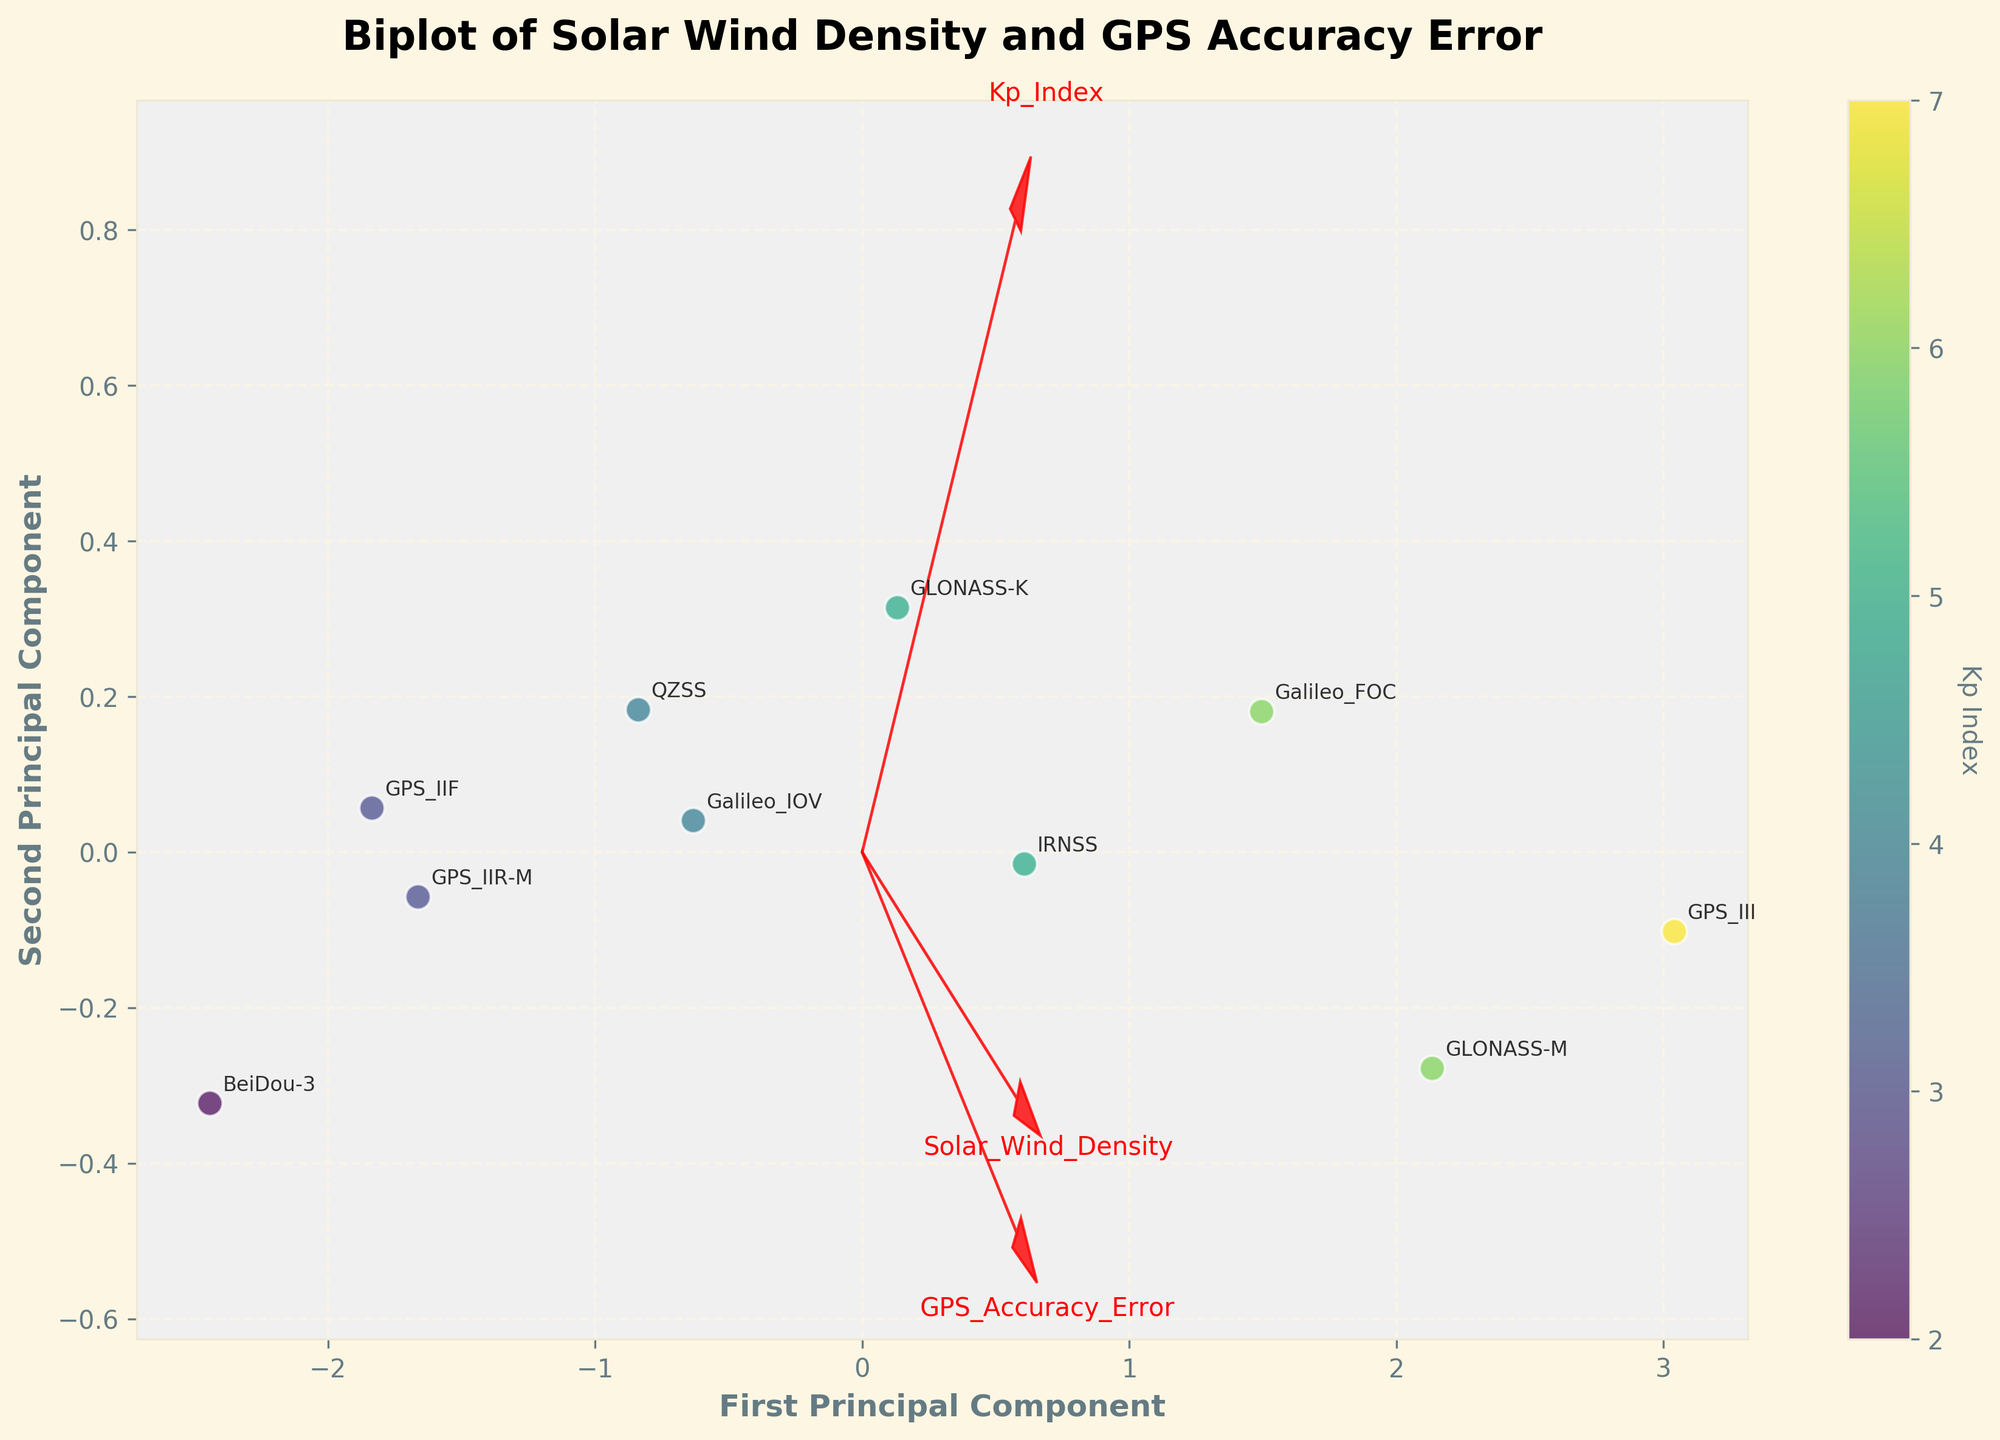How many principal components are represented on the axes of the biplot? The figure specifically shows two principal components, which can be inferred by the labels "First Principal Component" and "Second Principal Component" on the x and y axes.
Answer: 2 Which star's size is used to indicate the Kp Index in the biplot? The figure uses colors to represent the Kp Index, as indicated by the color bar placed alongside the plot. There is no information given about the size of stars representing Kp Index.
Answer: Colors What does a strong directional arrow of a feature indicate in this biplot? In the biplot, a strong directional arrow for a feature indicates that the feature contributes significantly to the principal components' axes. Longer arrows generally suggest a higher correlation with the components.
Answer: Significant contribution Which satellite is most aligned with higher values of the Second Principal Component? By observing the annotations on the figure, we see that the satellite "GPS_III," associated with the highest second principal component value, is furthest along the vertical axis.
Answer: GPS_III What is the correlation between "Kp_Index" and the first principal component? To find this, we need to look at the direction and length of the arrow for the "Kp_Index." Since "Kp_Index" arrow points mainly in the direction of the x-axis (positive first principal component), it implies a strong positive correlation with the first principal component.
Answer: Strong positive correlation Which satellite has the lowest GPS Accuracy Error values among the plotted data? We need to identify the data points closer to the origin in the direction of the "GPS_Accuracy_Error" arrow since it signifies lower values. "BeiDou-3" appears to be closest in this direction.
Answer: BeiDou-3 Does the solar wind density generally align more with the first or second principal component? By examining the direction of the "Solar_Wind_Density" arrow in the plot, we see it is aligned more with the first principal component (x-axis) than with the second principal component (y-axis).
Answer: First principal component How does the GLONASS-K satellite perform in terms of GPS Accuracy Error compared to Galileo_IOV? To compare, observe the positions of GLONASS-K and Galileo_IOV in relation to the "GPS_Accuracy_Error" arrow. "GLONASS-K" is further from the origin along this arrow, indicating worse GPS Accuracy Error compared to "Galileo_IOV."
Answer: Worse Which satellite shows the highest Kp Index based on the figure? By looking at the color scale and the corresponding annotations, "GPS_III" is represented with the darkest shade, which indicates the highest Kp Index value.
Answer: GPS_III Is there any noticeable relationship between the Kp Index and the accuracy error in GPS systems? By analyzing the color of data points and their positions relative to the "GPS_Accuracy_Error" arrow, we can observe a trend where points with higher Kp Index (darker colors) tend to have higher GPS Accuracy Errors, indicating a potential relationship.
Answer: Yes 